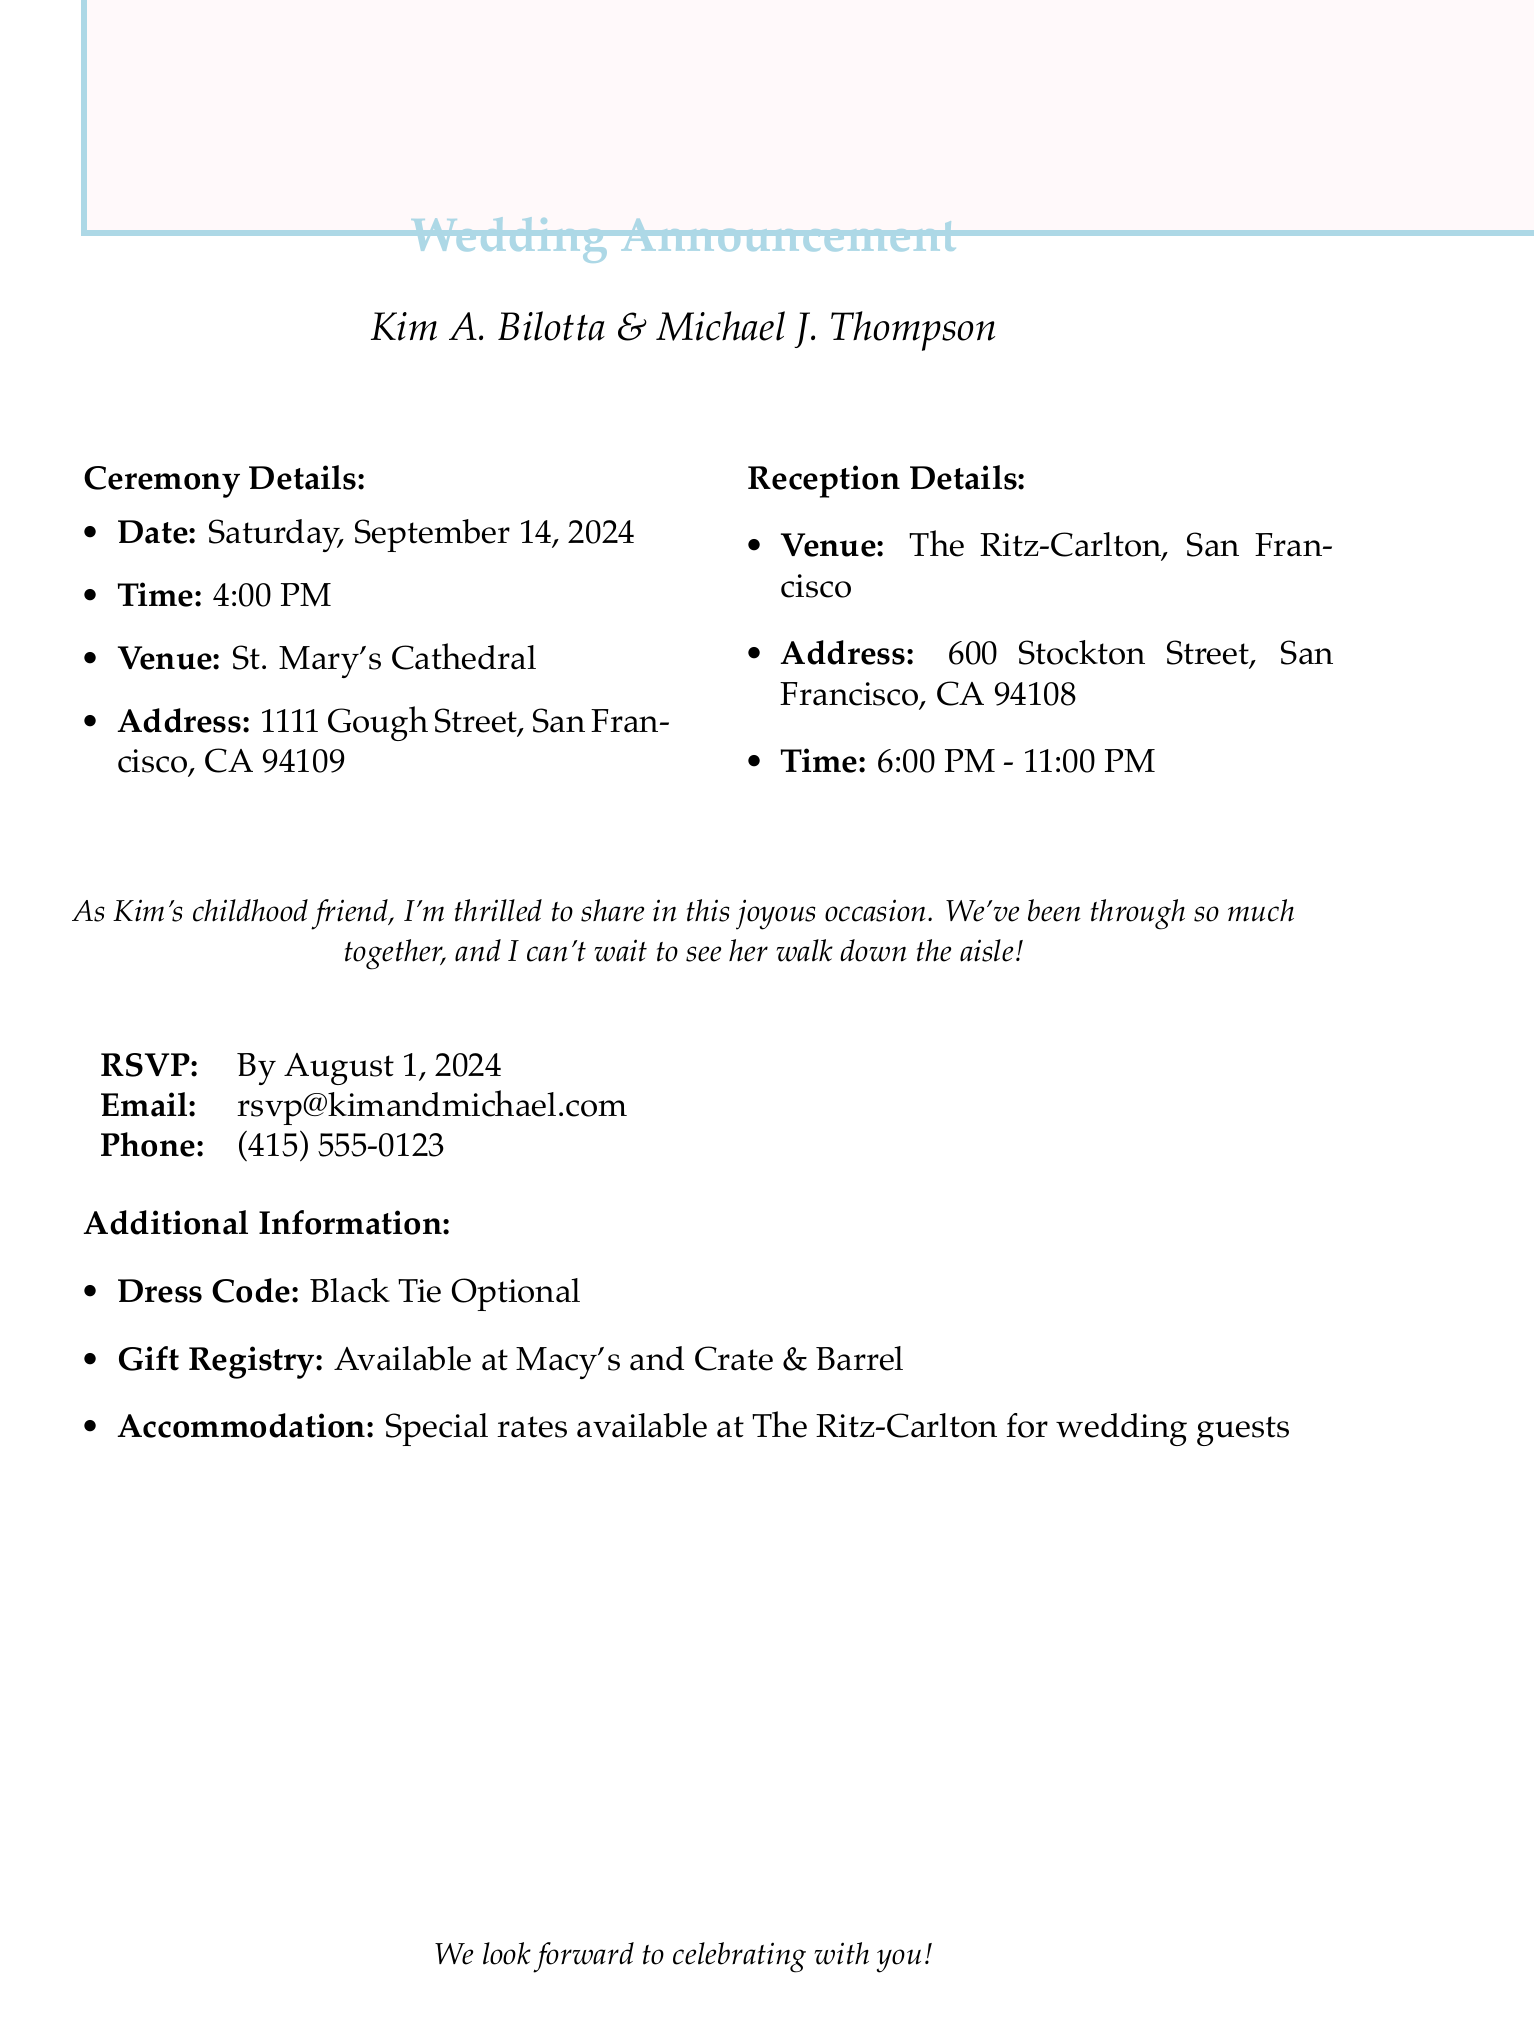What is the name of the bride? The document specifies the bride's name as Kim A. Bilotta.
Answer: Kim A. Bilotta What is the date of the wedding ceremony? The document provides the wedding ceremony date as Saturday, September 14, 2024.
Answer: Saturday, September 14, 2024 What is the address of the reception venue? The document states the reception address is 600 Stockton Street, San Francisco, CA 94108.
Answer: 600 Stockton Street, San Francisco, CA 94108 What is the RSVP deadline? The document clearly states that the RSVP deadline is August 1, 2024.
Answer: August 1, 2024 What is the dress code for the wedding? The document mentions that the dress code is Black Tie Optional.
Answer: Black Tie Optional What venue is the wedding reception being held at? The document specifies that the reception will be held at The Ritz-Carlton, San Francisco.
Answer: The Ritz-Carlton, San Francisco How long will the reception last? The document indicates that the reception time is from 6:00 PM to 11:00 PM.
Answer: 6:00 PM - 11:00 PM Who is the groom? The document lists the groom's name as Michael J. Thompson.
Answer: Michael J. Thompson What message does the childhood friend express? The personal message in the document states they are thrilled to share in Kim's joyous occasion.
Answer: Thrilled to share in this joyous occasion 